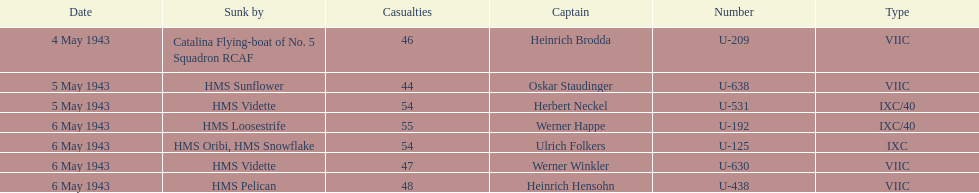How many captains are listed? 7. 